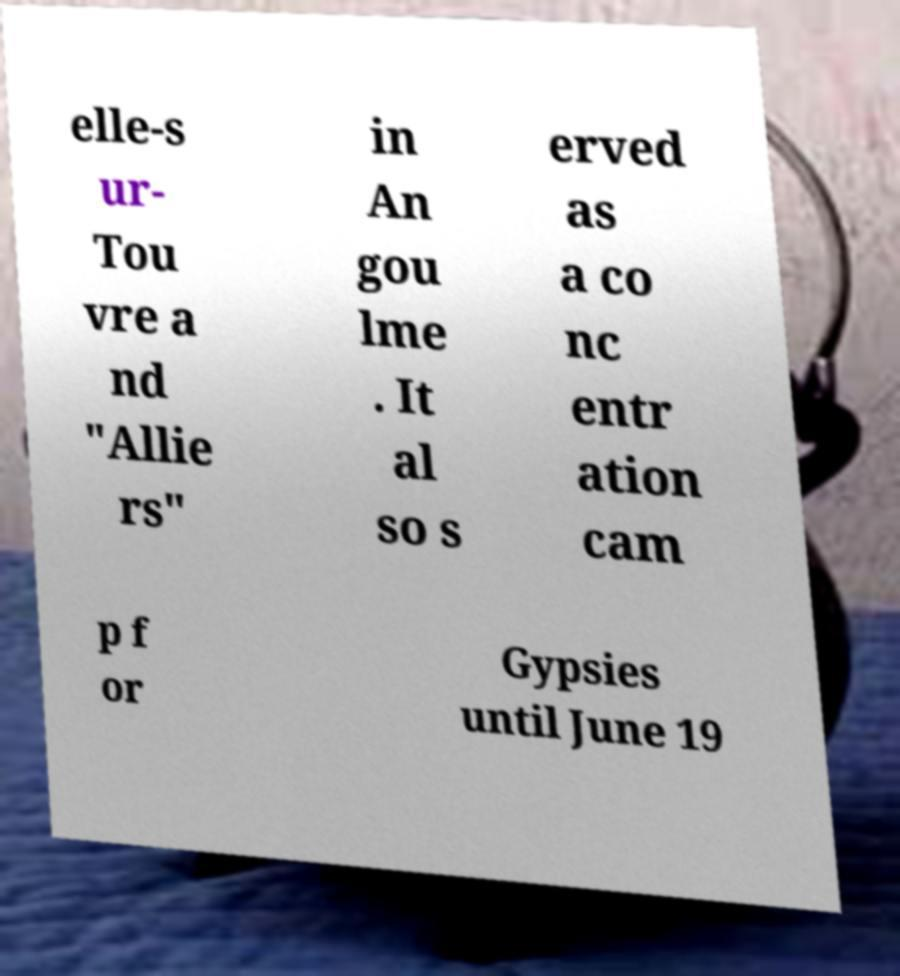Please read and relay the text visible in this image. What does it say? elle-s ur- Tou vre a nd "Allie rs" in An gou lme . It al so s erved as a co nc entr ation cam p f or Gypsies until June 19 